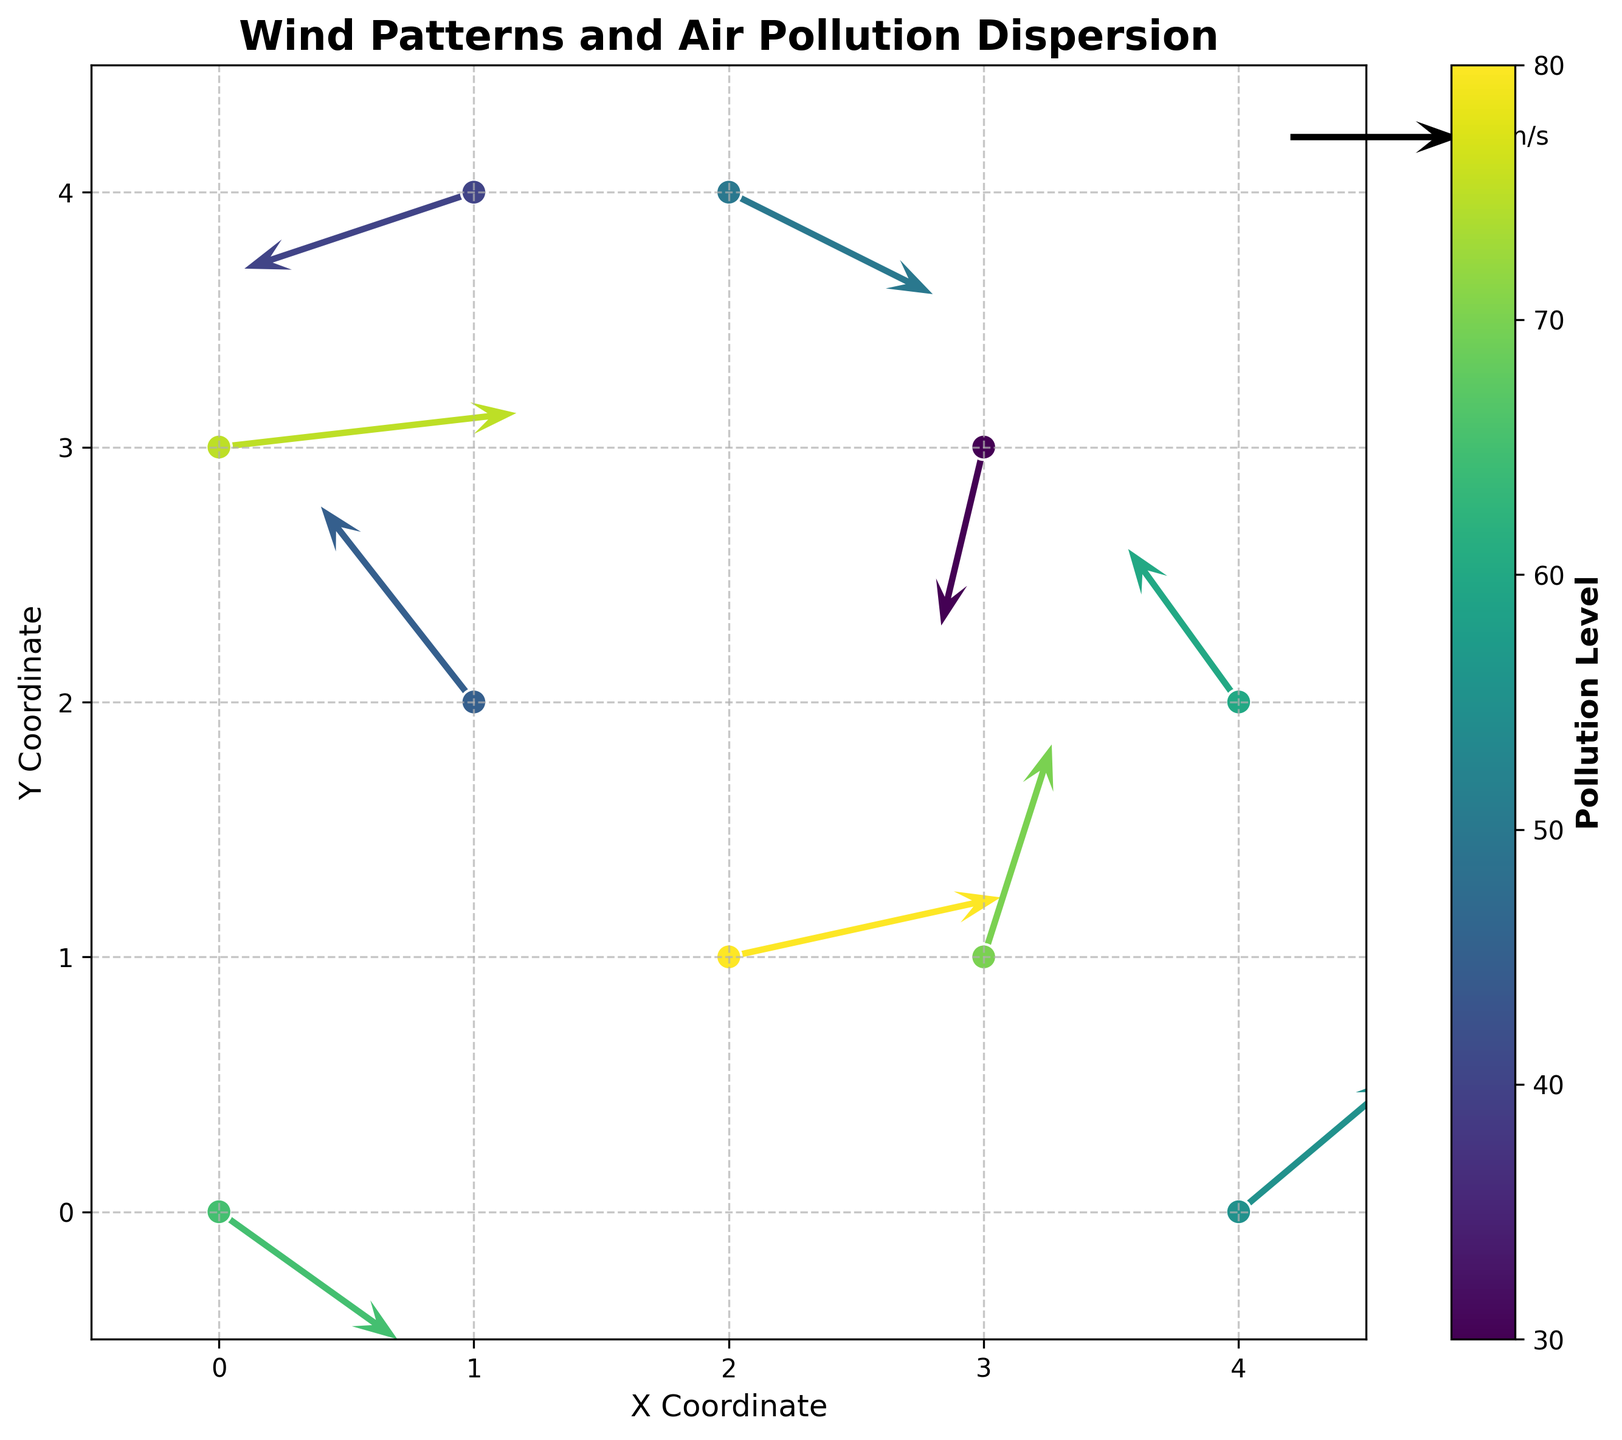Which city district has the highest pollution level? Look for the highest color intensity point on the colorbar and match it with the corresponding point on the plot; the point at coordinates (2,1) has the highest pollution level of 80.
Answer: (2,1) What is the wind speed and direction at the district with coordinates (3,3)? Locate the point at (3,3) and observe the associated vector; the u component is -0.5, and the v component is -2.1. Calculate the magnitude as sqrt((-0.5)^2 + (-2.1)^2) and note the direction.
Answer: Speed is approximately 2.15 m/s towards south-southwest Compare the pollution levels between the districts at (1,2) and (4,0). Which one is higher? Check the color intensity for points at (1,2) and (4,0); (1,2) is 45 and (4,0) is 55.
Answer: (4,0) is higher at 55 What is the difference in pollution levels between the highest and lowest points on the plot? Identify the highest pollution level (80 at (2,1)) and the lowest (30 at (3,3)), then subtract 30 from 80.
Answer: 50 How does the direction of the wind impact the pollution level at (0,3)? Observe the vector at (0,3). The wind is moving eastward with a high u component of 3.5 and a low v component of 0.4.
Answer: It likely helps to disperse the pollution towards the east Which direction shows the most consistent wind patterns? Look at the general direction of most vectors, noting if there’s a prevailing direction (e.g., more vectors pointing northeast or southwest). Consistency can be seen towards the northeast.
Answer: Northeast What is the pollution level for the district with the central coordinate (2,1)? Identify the color and match it on the colorbar; (2,1) closely aligns with a pollution level of 80.
Answer: 80 Identify the district with a wind vector pointing primarily downward. Locate vectors with significant negative y-components (v); the point at (3,3) has a vector pointing downward with v = -2.1.
Answer: (3,3) What range of the colorbar represents the highest concentration of pollution? Analyze the colorbar's values and colors; the darkest color around the value of 80 represents the highest concentration.
Answer: 70-80 Which district experiences the strongest wind magnitude? Calculate the magnitude of each vector using sqrt(u^2 + v^2) and find the highest value; the point (0,3) has vector 3.5 and 0.4, resulting in 3.52 m/s.
Answer: (0,3) 